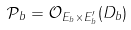Convert formula to latex. <formula><loc_0><loc_0><loc_500><loc_500>\mathcal { P } _ { b } = \mathcal { O } _ { E _ { b } \times E ^ { \prime } _ { b } } ( D _ { b } )</formula> 